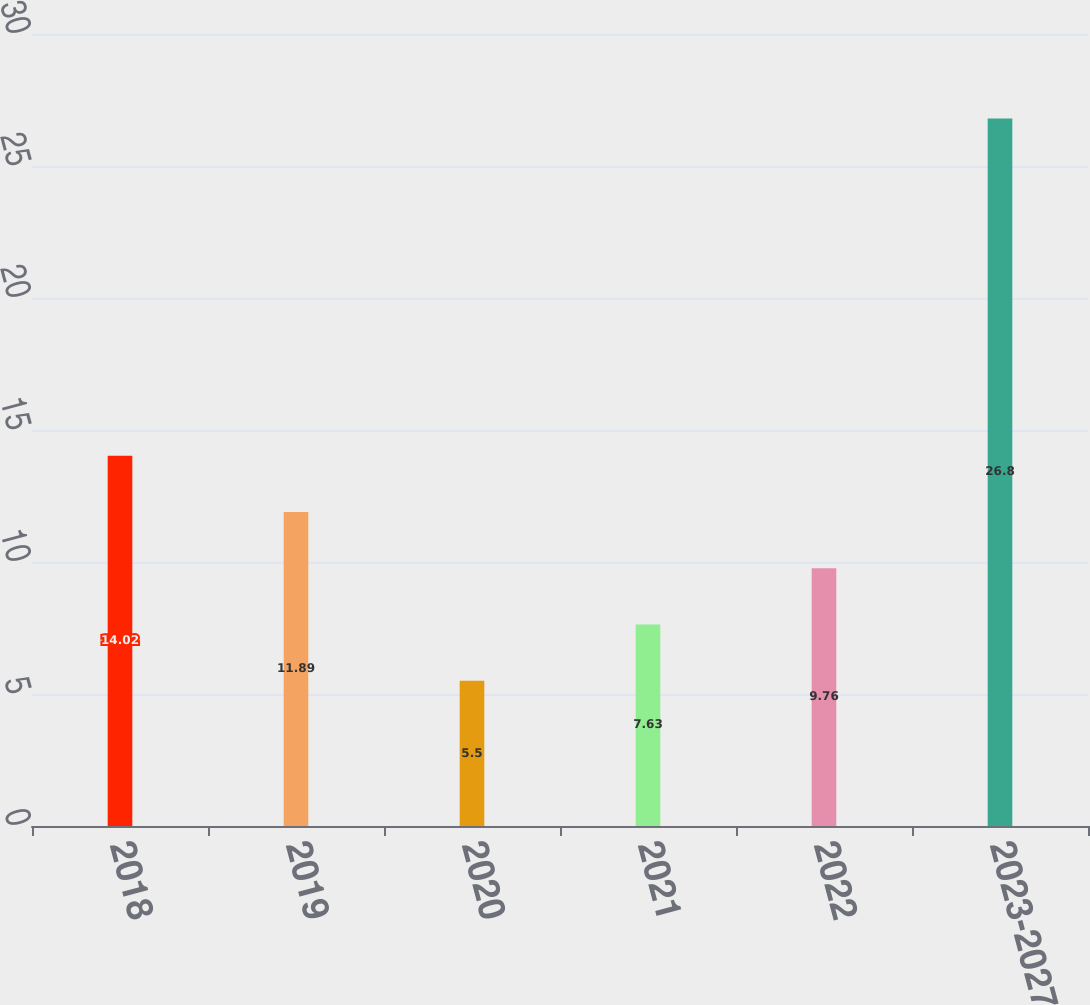<chart> <loc_0><loc_0><loc_500><loc_500><bar_chart><fcel>2018<fcel>2019<fcel>2020<fcel>2021<fcel>2022<fcel>2023-2027<nl><fcel>14.02<fcel>11.89<fcel>5.5<fcel>7.63<fcel>9.76<fcel>26.8<nl></chart> 